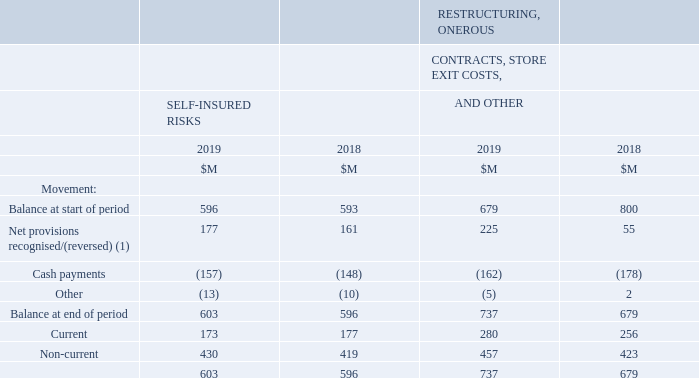Movements in total self‐insured risks, restructuring, onerous contracts, store exit costs, and other provisions
(1) The increase in restructuring, onerous contracts, and store exit costs in 2019 is primarily attributable to the recognition of provisions associated with the BIG W network review as outlined in Note 1.4.
A provision is recognised when the Group has a present legal or constructive obligation as a result of a past event, it is probable that an outflow of economic benefits will be required to settle the obligation, and a reliable estimate can be made as to the amount of the obligation. The amount recognised is the best estimate of the consideration required to settle the present obligation at the reporting date, taking into account the risks and uncertainties surrounding the obligation.
A liability is recognised for benefits accruing to employees in respect of annual leave and long service leave.
Liabilities expected to be settled within 12 months are measured at their nominal values using the remuneration rate expected to apply at the time of settlement.
Liabilities which are not expected to be settled within 12 months are measured as the present value of the estimated future cash outflows to be made by the Group in respect of services provided by employees up to the reporting date.
The provision for self-insured risks primarily represents the estimated liability for workers’ compensation and public liability claims.
Provision for restructuring is recognised when the Group has developed a detailed formal plan for the restructuring and has raised a valid expectation in those affected by the restructuring that the restructuring will occur.
An onerous contract is a contract in which the unavoidable costs of meeting the obligations under the contract exceed the economic benefits expected to be received under it. The unavoidable costs under a contract reflect the least net cost of exiting from the contract, which is the lower of the cost of fulfilling it and any compensation or penalties arising from failure to fulfil it.
When is provision for restructuring recognised? Provision for restructuring is recognised when the group has developed a detailed formal plan for the restructuring and has raised a valid expectation in those affected by the restructuring that the restructuring will occur. What is the amount of current self-insured risks in 2019?
Answer scale should be: million. 173. What is the units used in the table? $m. What is the nominal difference of non-current self-insured risks between 2019 and 2018?
Answer scale should be: million. 430 - 419 
Answer: 11. What is the percentage constitution of current self-insured risks in the total self-insured risks in 2019?
Answer scale should be: percent. 173/603 
Answer: 28.69. What is the average cash payments for self-insured risks for both years?
Answer scale should be: million. (157 + 148)/2 
Answer: 152.5. 